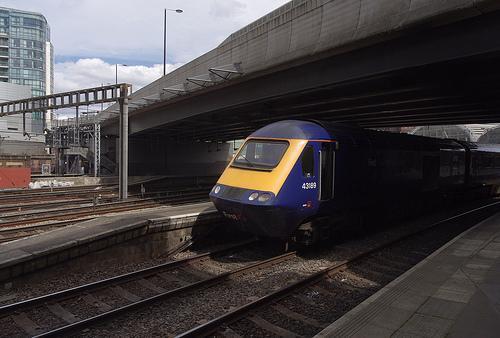How many trains are in this picture?
Give a very brief answer. 1. 